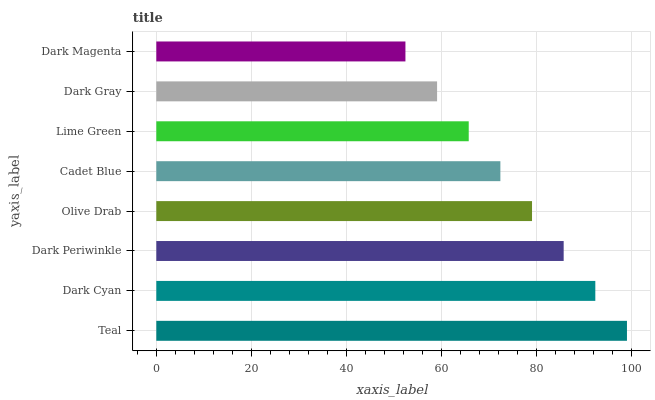Is Dark Magenta the minimum?
Answer yes or no. Yes. Is Teal the maximum?
Answer yes or no. Yes. Is Dark Cyan the minimum?
Answer yes or no. No. Is Dark Cyan the maximum?
Answer yes or no. No. Is Teal greater than Dark Cyan?
Answer yes or no. Yes. Is Dark Cyan less than Teal?
Answer yes or no. Yes. Is Dark Cyan greater than Teal?
Answer yes or no. No. Is Teal less than Dark Cyan?
Answer yes or no. No. Is Olive Drab the high median?
Answer yes or no. Yes. Is Cadet Blue the low median?
Answer yes or no. Yes. Is Dark Cyan the high median?
Answer yes or no. No. Is Lime Green the low median?
Answer yes or no. No. 